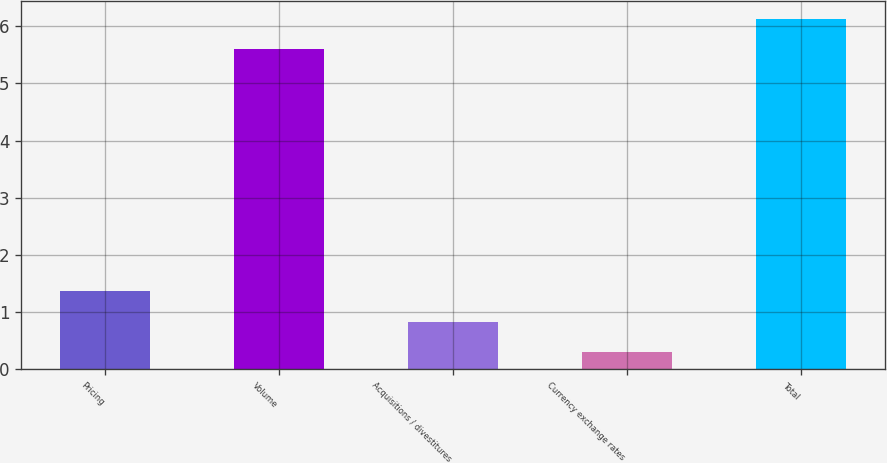Convert chart. <chart><loc_0><loc_0><loc_500><loc_500><bar_chart><fcel>Pricing<fcel>Volume<fcel>Acquisitions / divestitures<fcel>Currency exchange rates<fcel>Total<nl><fcel>1.36<fcel>5.6<fcel>0.83<fcel>0.3<fcel>6.13<nl></chart> 